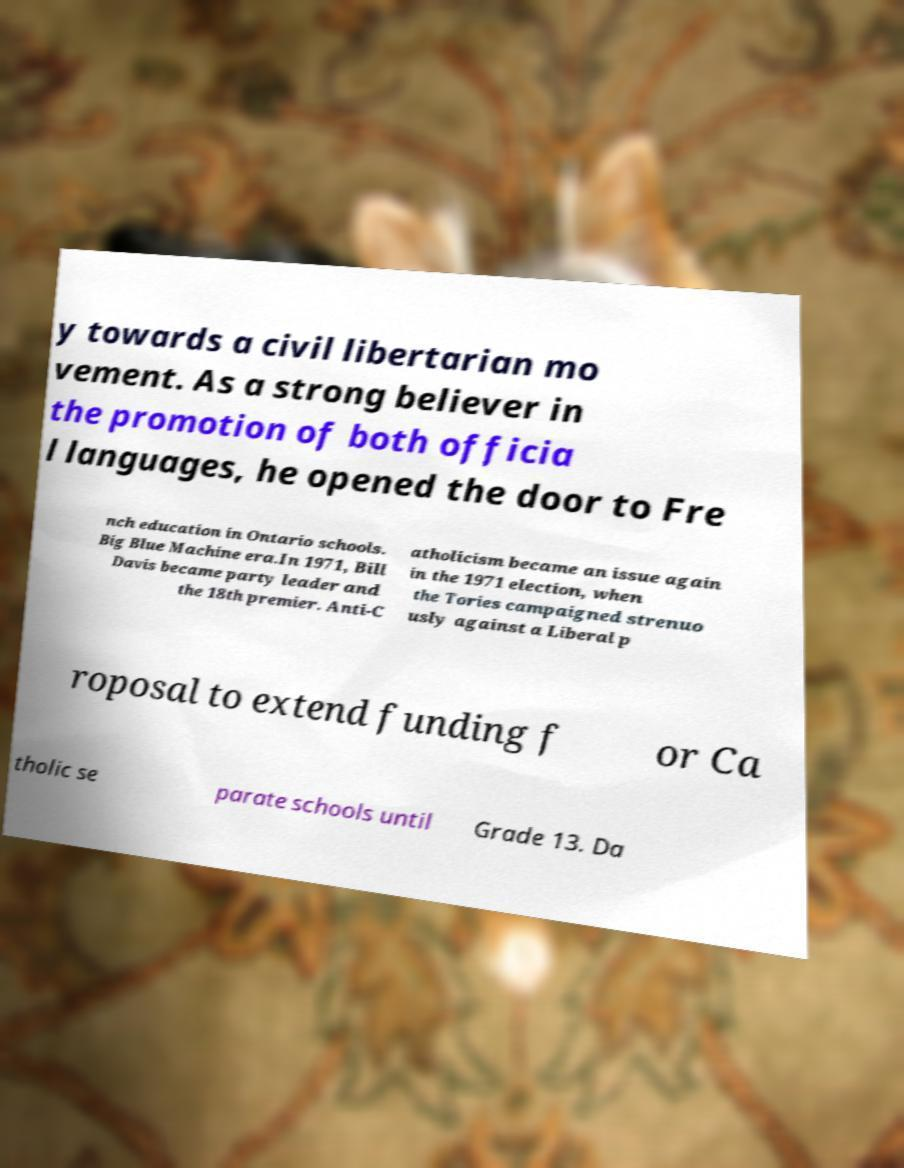Please read and relay the text visible in this image. What does it say? y towards a civil libertarian mo vement. As a strong believer in the promotion of both officia l languages, he opened the door to Fre nch education in Ontario schools. Big Blue Machine era.In 1971, Bill Davis became party leader and the 18th premier. Anti-C atholicism became an issue again in the 1971 election, when the Tories campaigned strenuo usly against a Liberal p roposal to extend funding f or Ca tholic se parate schools until Grade 13. Da 